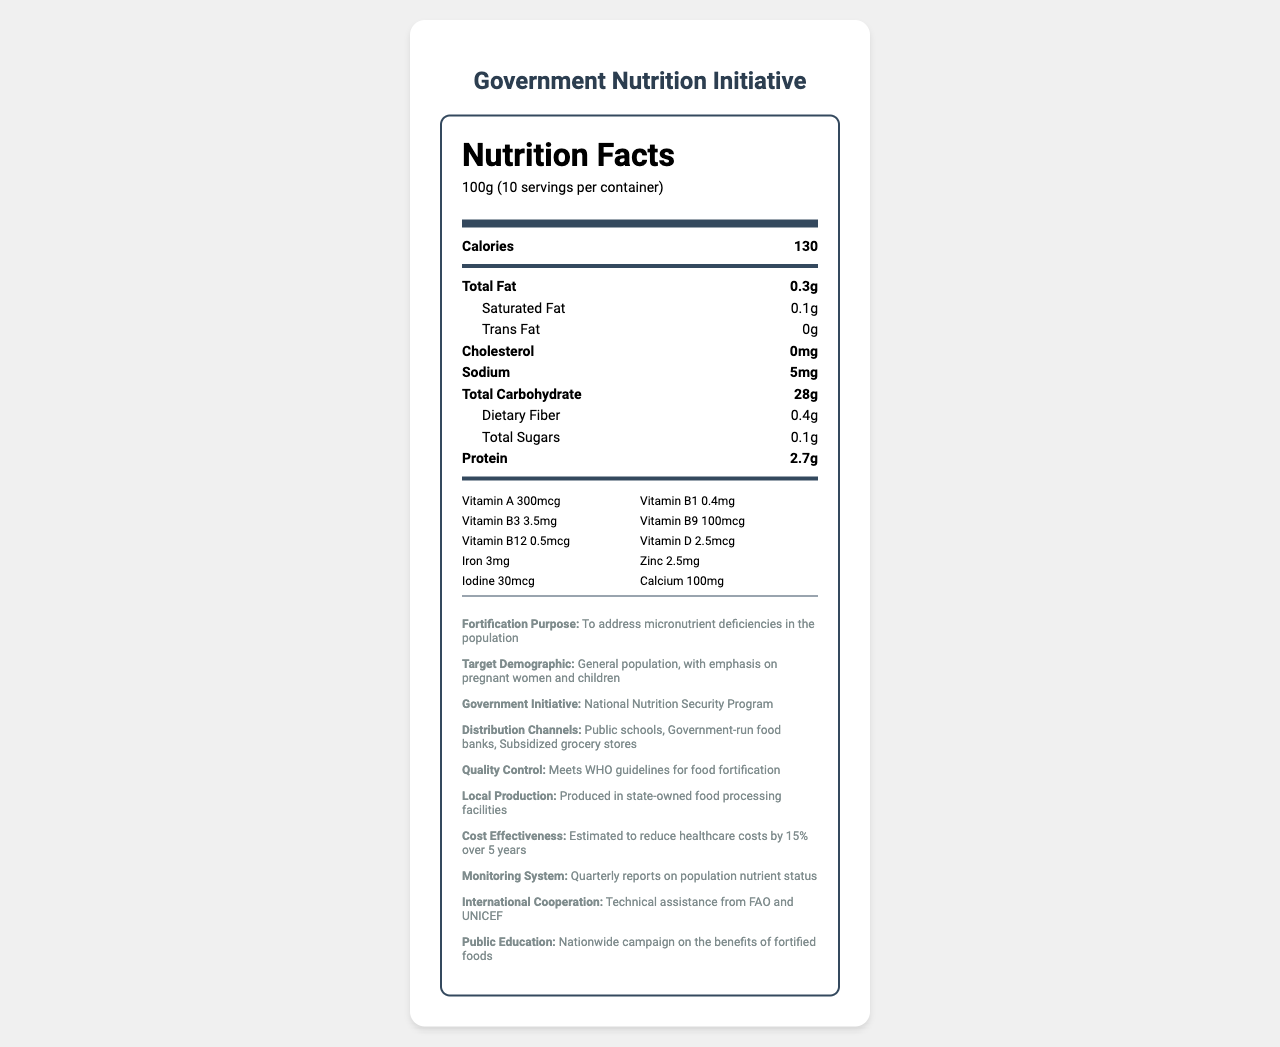what is the serving size of FortifyNation Enriched Rice? The document specifies the serving size as 100g under the "Nutrition Facts" section.
Answer: 100g How many servings per container are there? The document states that there are 10 servings per container under the "Nutrition Facts" section.
Answer: 10 What vitamins and minerals are listed on the nutrition label? The section detailing vitamins and minerals lists Vitamin A, Vitamin B1, Vitamin B3, Vitamin B9, Vitamin B12, Vitamin D, iron, zinc, iodine, and calcium.
Answer: Vitamins A, B1, B3, B9, B12, D, iron, zinc, iodine, calcium What is the fortification purpose of FortifyNation Enriched Rice? The "additional info" section under "Fortification Purpose" states that the purpose is to address micronutrient deficiencies in the population.
Answer: To address micronutrient deficiencies in the population How many mcg of Vitamin D are in each serving? The nutrition label lists Vitamin D as 2.5 mcg under the vitamins section.
Answer: 2.5 mcg Which of the following is NOT a distribution channel mentioned in the document? A. Public schools B. Private hospitals C. Government-run food banks D. Subsidized grocery stores The document lists Public schools, Government-run food banks, and Subsidized grocery stores but does not mention Private hospitals.
Answer: B Which vitamin has the highest amount per serving? A. Vitamin A B. Vitamin B1 C. Vitamin B3 D. Vitamin B12 Vitamin A has 300 mcg per serving, which is higher compared to 0.4mg of Vitamin B1, 3.5mg of Vitamin B3, and 0.5 mcg of Vitamin B12.
Answer: A Does the document mention public education on the benefits of fortified foods? The "additional info" section under "Public Education" states that there is a nationwide campaign on the benefits of fortified foods.
Answer: Yes How does the initiative aim to reduce healthcare costs? The "cost effectiveness" part of the "additional info" section mentions that the initiative is estimated to reduce healthcare costs by 15% over 5 years.
Answer: By 15% over 5 years What are the main points covered in the document? The main points in the document include detailed nutrition facts, the fortification purpose, target demographic, distribution channels, and quality control measures. Additionally, it highlights the expected cost-effectiveness and public education campaign supporting the initiative.
Answer: The document provides nutrition information for FortifyNation Enriched Rice, detailing its vitamin and mineral content, serving size, and servings per container. It also outlines the purpose of the food fortification program, target demographic, government initiative, distribution channels, quality control, cost-effectiveness, and public education efforts. What is the local production process of FortifyNation Enriched Rice? The document states that the rice is locally produced in state-owned food processing facilities, but it does not provide detailed information on the production process itself.
Answer: Cannot be determined 